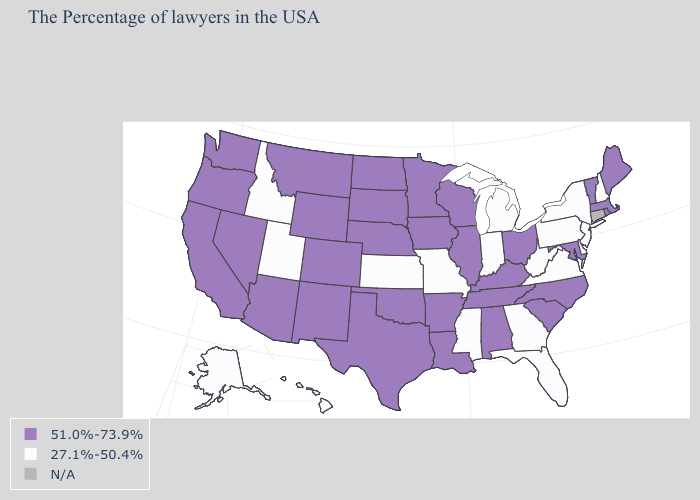Name the states that have a value in the range 27.1%-50.4%?
Give a very brief answer. New Hampshire, New York, New Jersey, Delaware, Pennsylvania, Virginia, West Virginia, Florida, Georgia, Michigan, Indiana, Mississippi, Missouri, Kansas, Utah, Idaho, Alaska, Hawaii. Name the states that have a value in the range 27.1%-50.4%?
Short answer required. New Hampshire, New York, New Jersey, Delaware, Pennsylvania, Virginia, West Virginia, Florida, Georgia, Michigan, Indiana, Mississippi, Missouri, Kansas, Utah, Idaho, Alaska, Hawaii. Does the map have missing data?
Quick response, please. Yes. What is the value of Florida?
Be succinct. 27.1%-50.4%. Which states have the lowest value in the USA?
Short answer required. New Hampshire, New York, New Jersey, Delaware, Pennsylvania, Virginia, West Virginia, Florida, Georgia, Michigan, Indiana, Mississippi, Missouri, Kansas, Utah, Idaho, Alaska, Hawaii. What is the value of Texas?
Keep it brief. 51.0%-73.9%. How many symbols are there in the legend?
Short answer required. 3. Does the first symbol in the legend represent the smallest category?
Concise answer only. No. Which states hav the highest value in the West?
Concise answer only. Wyoming, Colorado, New Mexico, Montana, Arizona, Nevada, California, Washington, Oregon. How many symbols are there in the legend?
Answer briefly. 3. What is the value of New Jersey?
Concise answer only. 27.1%-50.4%. Which states have the lowest value in the MidWest?
Be succinct. Michigan, Indiana, Missouri, Kansas. Name the states that have a value in the range 51.0%-73.9%?
Short answer required. Maine, Massachusetts, Rhode Island, Vermont, Maryland, North Carolina, South Carolina, Ohio, Kentucky, Alabama, Tennessee, Wisconsin, Illinois, Louisiana, Arkansas, Minnesota, Iowa, Nebraska, Oklahoma, Texas, South Dakota, North Dakota, Wyoming, Colorado, New Mexico, Montana, Arizona, Nevada, California, Washington, Oregon. What is the value of Maine?
Be succinct. 51.0%-73.9%. Is the legend a continuous bar?
Short answer required. No. 